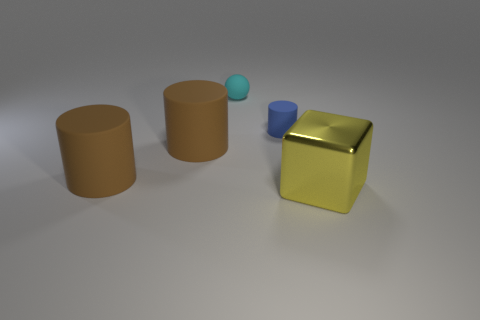What is the purpose of the cylinder objects and why do they appear to be unfinished? The cylinders in the image appear to be unfinished because they lack any discernible features or openings that might suggest a specific function. They could be interpreted as simplistic representations of containers or as abstract elements in a digital composition, designed more to explore form and light rather than practical usage. 